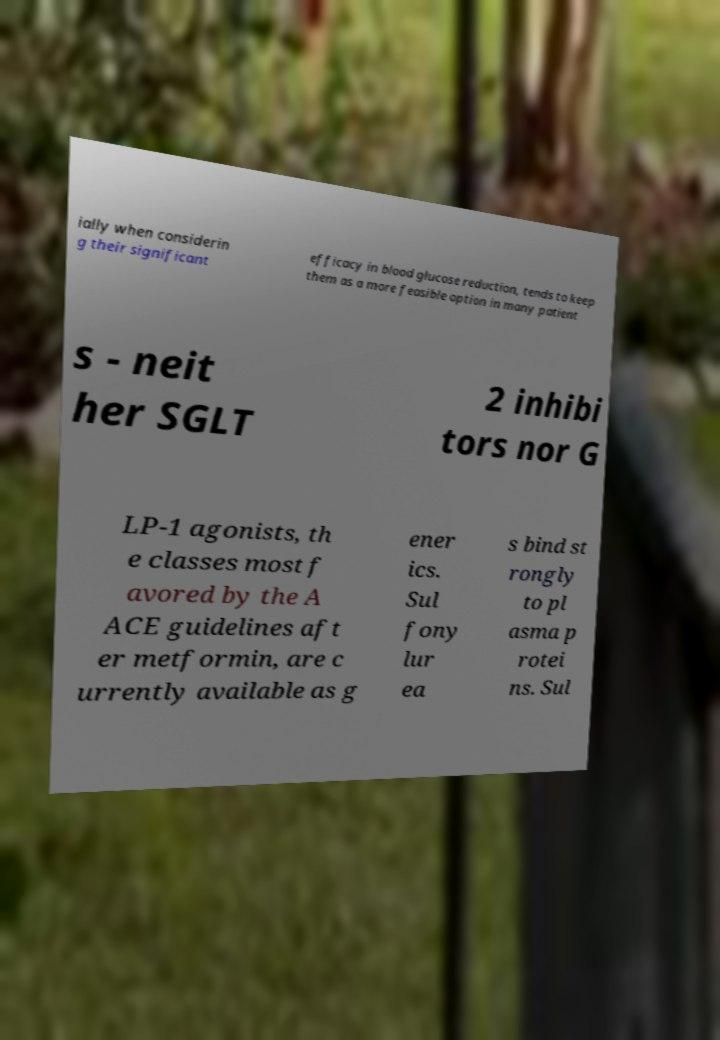There's text embedded in this image that I need extracted. Can you transcribe it verbatim? ially when considerin g their significant efficacy in blood glucose reduction, tends to keep them as a more feasible option in many patient s - neit her SGLT 2 inhibi tors nor G LP-1 agonists, th e classes most f avored by the A ACE guidelines aft er metformin, are c urrently available as g ener ics. Sul fony lur ea s bind st rongly to pl asma p rotei ns. Sul 